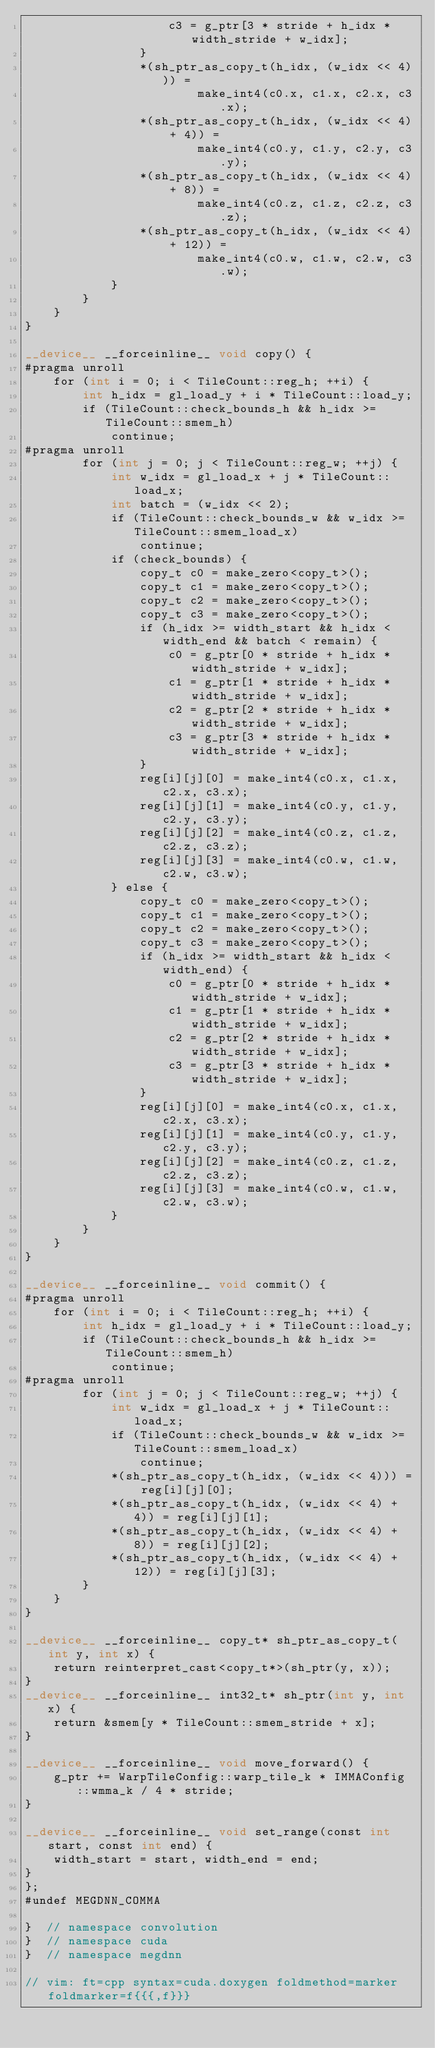Convert code to text. <code><loc_0><loc_0><loc_500><loc_500><_Cuda_>                    c3 = g_ptr[3 * stride + h_idx * width_stride + w_idx];
                }
                *(sh_ptr_as_copy_t(h_idx, (w_idx << 4))) =
                        make_int4(c0.x, c1.x, c2.x, c3.x);
                *(sh_ptr_as_copy_t(h_idx, (w_idx << 4) + 4)) =
                        make_int4(c0.y, c1.y, c2.y, c3.y);
                *(sh_ptr_as_copy_t(h_idx, (w_idx << 4) + 8)) =
                        make_int4(c0.z, c1.z, c2.z, c3.z);
                *(sh_ptr_as_copy_t(h_idx, (w_idx << 4) + 12)) =
                        make_int4(c0.w, c1.w, c2.w, c3.w);
            }
        }
    }
}

__device__ __forceinline__ void copy() {
#pragma unroll
    for (int i = 0; i < TileCount::reg_h; ++i) {
        int h_idx = gl_load_y + i * TileCount::load_y;
        if (TileCount::check_bounds_h && h_idx >= TileCount::smem_h)
            continue;
#pragma unroll
        for (int j = 0; j < TileCount::reg_w; ++j) {
            int w_idx = gl_load_x + j * TileCount::load_x;
            int batch = (w_idx << 2);
            if (TileCount::check_bounds_w && w_idx >= TileCount::smem_load_x)
                continue;
            if (check_bounds) {
                copy_t c0 = make_zero<copy_t>();
                copy_t c1 = make_zero<copy_t>();
                copy_t c2 = make_zero<copy_t>();
                copy_t c3 = make_zero<copy_t>();
                if (h_idx >= width_start && h_idx < width_end && batch < remain) {
                    c0 = g_ptr[0 * stride + h_idx * width_stride + w_idx];
                    c1 = g_ptr[1 * stride + h_idx * width_stride + w_idx];
                    c2 = g_ptr[2 * stride + h_idx * width_stride + w_idx];
                    c3 = g_ptr[3 * stride + h_idx * width_stride + w_idx];
                }
                reg[i][j][0] = make_int4(c0.x, c1.x, c2.x, c3.x);
                reg[i][j][1] = make_int4(c0.y, c1.y, c2.y, c3.y);
                reg[i][j][2] = make_int4(c0.z, c1.z, c2.z, c3.z);
                reg[i][j][3] = make_int4(c0.w, c1.w, c2.w, c3.w);
            } else {
                copy_t c0 = make_zero<copy_t>();
                copy_t c1 = make_zero<copy_t>();
                copy_t c2 = make_zero<copy_t>();
                copy_t c3 = make_zero<copy_t>();
                if (h_idx >= width_start && h_idx < width_end) {
                    c0 = g_ptr[0 * stride + h_idx * width_stride + w_idx];
                    c1 = g_ptr[1 * stride + h_idx * width_stride + w_idx];
                    c2 = g_ptr[2 * stride + h_idx * width_stride + w_idx];
                    c3 = g_ptr[3 * stride + h_idx * width_stride + w_idx];
                }
                reg[i][j][0] = make_int4(c0.x, c1.x, c2.x, c3.x);
                reg[i][j][1] = make_int4(c0.y, c1.y, c2.y, c3.y);
                reg[i][j][2] = make_int4(c0.z, c1.z, c2.z, c3.z);
                reg[i][j][3] = make_int4(c0.w, c1.w, c2.w, c3.w);
            }
        }
    }
}

__device__ __forceinline__ void commit() {
#pragma unroll
    for (int i = 0; i < TileCount::reg_h; ++i) {
        int h_idx = gl_load_y + i * TileCount::load_y;
        if (TileCount::check_bounds_h && h_idx >= TileCount::smem_h)
            continue;
#pragma unroll
        for (int j = 0; j < TileCount::reg_w; ++j) {
            int w_idx = gl_load_x + j * TileCount::load_x;
            if (TileCount::check_bounds_w && w_idx >= TileCount::smem_load_x)
                continue;
            *(sh_ptr_as_copy_t(h_idx, (w_idx << 4))) = reg[i][j][0];
            *(sh_ptr_as_copy_t(h_idx, (w_idx << 4) + 4)) = reg[i][j][1];
            *(sh_ptr_as_copy_t(h_idx, (w_idx << 4) + 8)) = reg[i][j][2];
            *(sh_ptr_as_copy_t(h_idx, (w_idx << 4) + 12)) = reg[i][j][3];
        }
    }
}

__device__ __forceinline__ copy_t* sh_ptr_as_copy_t(int y, int x) {
    return reinterpret_cast<copy_t*>(sh_ptr(y, x));
}
__device__ __forceinline__ int32_t* sh_ptr(int y, int x) {
    return &smem[y * TileCount::smem_stride + x];
}

__device__ __forceinline__ void move_forward() {
    g_ptr += WarpTileConfig::warp_tile_k * IMMAConfig::wmma_k / 4 * stride;
}

__device__ __forceinline__ void set_range(const int start, const int end) {
    width_start = start, width_end = end;
}
};
#undef MEGDNN_COMMA

}  // namespace convolution
}  // namespace cuda
}  // namespace megdnn

// vim: ft=cpp syntax=cuda.doxygen foldmethod=marker foldmarker=f{{{,f}}}
</code> 